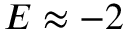Convert formula to latex. <formula><loc_0><loc_0><loc_500><loc_500>E \approx - 2</formula> 